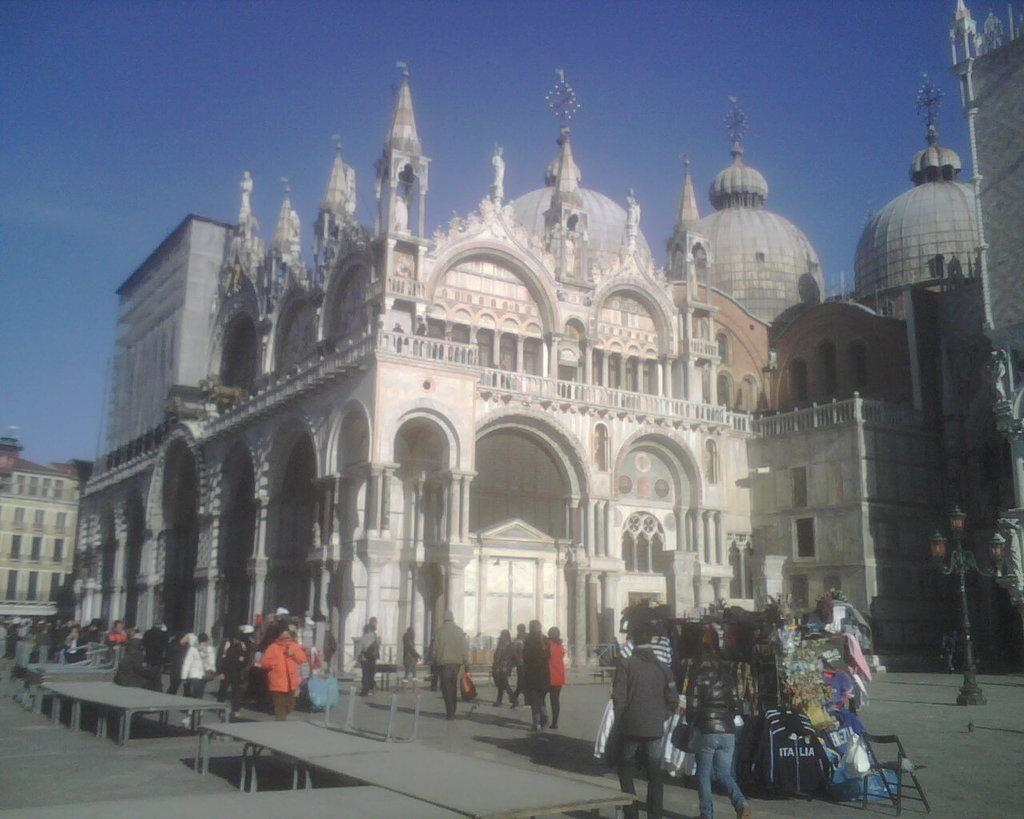What is happening in the image? There are persons standing in the image. Can you describe the objects in the right corner of the image? There are clothes placed on an object in the right corner of the image. What can be seen in the background of the image? There are buildings in the background of the image. How many cherries are on the wall in the image? There are no cherries or walls present in the image. 